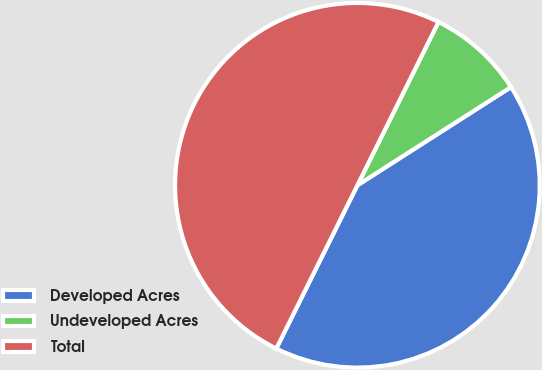<chart> <loc_0><loc_0><loc_500><loc_500><pie_chart><fcel>Developed Acres<fcel>Undeveloped Acres<fcel>Total<nl><fcel>41.39%<fcel>8.61%<fcel>50.0%<nl></chart> 